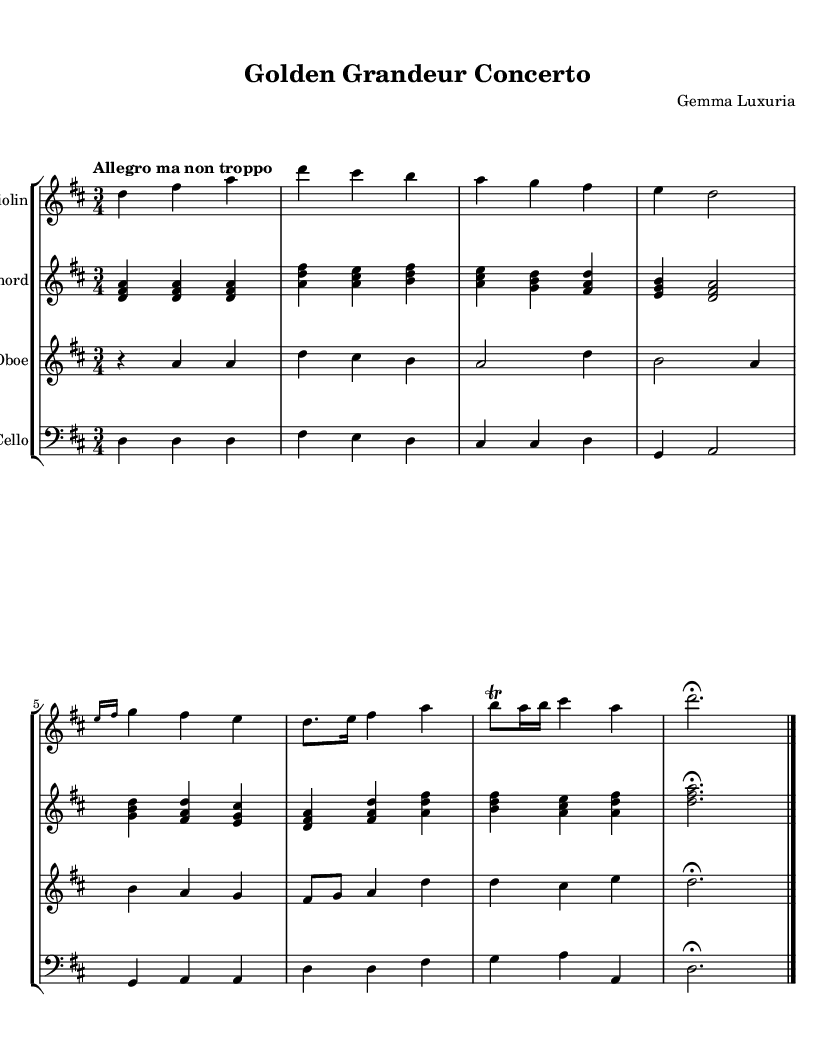What is the key signature of this music? The key signature is D major, which has two sharps: F# and C#. This can be identified by looking at the notation at the beginning of the staff, which indicates the sharps present.
Answer: D major What is the time signature of this music? The time signature is 3/4, which means there are three beats in each measure and the quarter note gets one beat. This is indicated by the fraction at the start of the score.
Answer: 3/4 What is the tempo marking of this piece? The tempo marking is "Allegro ma non troppo", which indicates a fast tempo that is not too fast. This marking is found above the first measure in the score.
Answer: Allegro ma non troppo How many instruments are featured in this concerto? There are four instruments featured in this concerto: the violin, harpsichord, oboe, and cello. The score lists all these instruments at the beginning of their respective staves.
Answer: Four Which instrument has the solo part? The instrument with the solo part is the gold-plated violin. The violin's music is presented on the first staff, indicating its leading role.
Answer: Gold-plated Violin What is unique about the instrumentation in this concerto? The instrumentation is unique due to all instruments being gold-plated. This is specified in the names of the instruments shown in the score.
Answer: Gold-plated instruments What is the last measure's indication? The last measure has a fermata, indicated by the symbol above it, which means to hold the note longer than its usual duration. The fermata can be observed over the d note making it stand out.
Answer: Fermata 